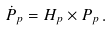Convert formula to latex. <formula><loc_0><loc_0><loc_500><loc_500>\dot { P } _ { p } = { H } _ { p } \times { P } _ { p } \, .</formula> 